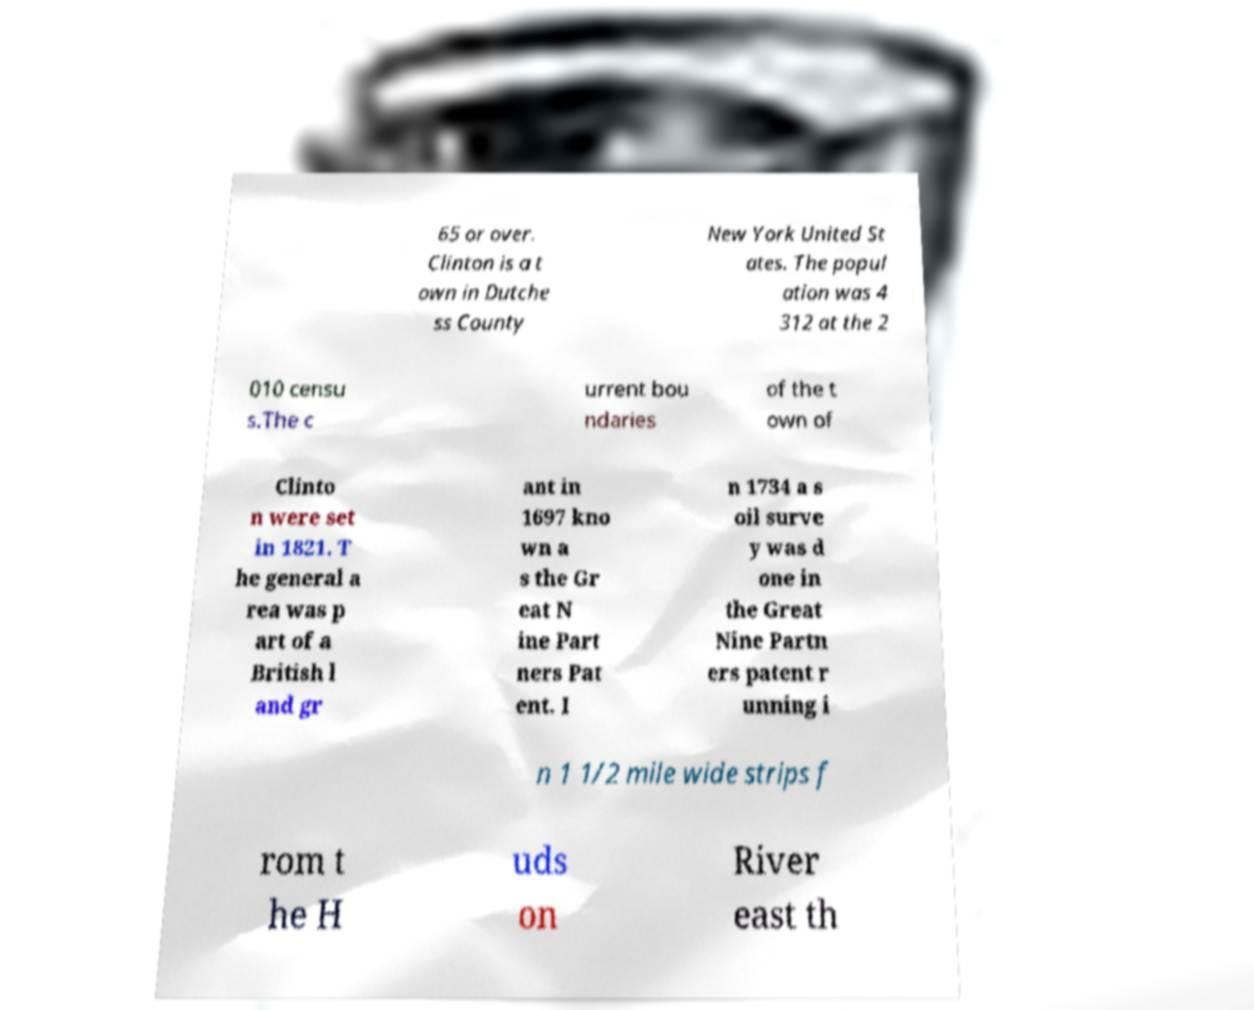Please identify and transcribe the text found in this image. 65 or over. Clinton is a t own in Dutche ss County New York United St ates. The popul ation was 4 312 at the 2 010 censu s.The c urrent bou ndaries of the t own of Clinto n were set in 1821. T he general a rea was p art of a British l and gr ant in 1697 kno wn a s the Gr eat N ine Part ners Pat ent. I n 1734 a s oil surve y was d one in the Great Nine Partn ers patent r unning i n 1 1/2 mile wide strips f rom t he H uds on River east th 